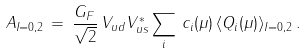<formula> <loc_0><loc_0><loc_500><loc_500>A _ { I = 0 , 2 } \, = \, \frac { G _ { F } } { \sqrt { 2 } } \, V _ { u d } V _ { u s } ^ { * } \sum _ { i } \, c _ { i } ( \mu ) \, \langle Q _ { i } ( \mu ) \rangle _ { I = 0 , 2 } \, .</formula> 